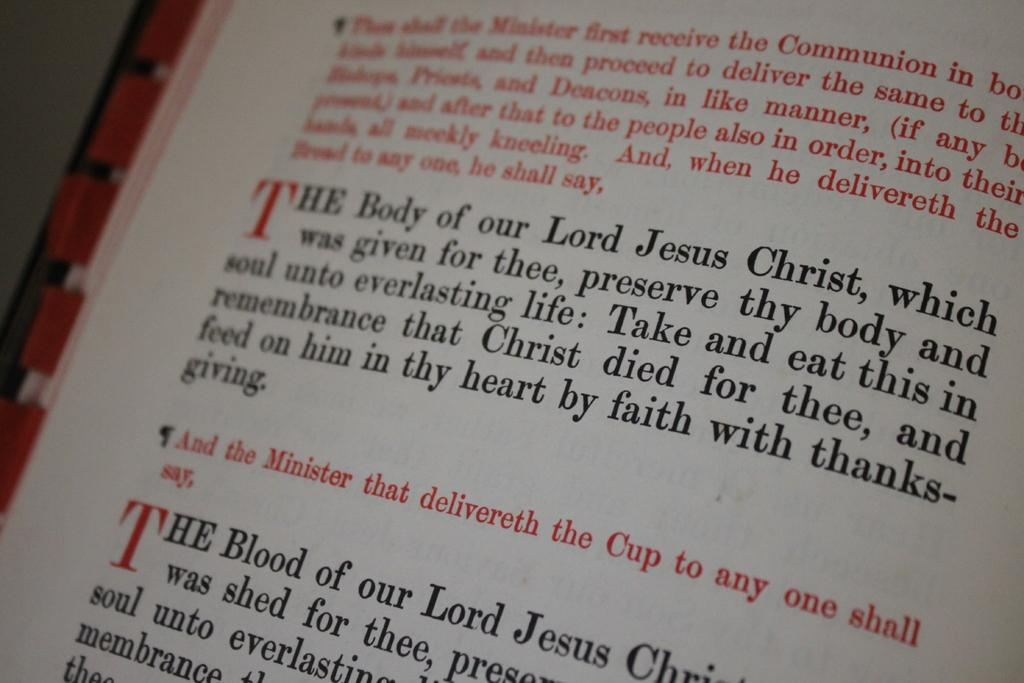<image>
Present a compact description of the photo's key features. Passage from the Bible with every first letter T capitalized and red. 